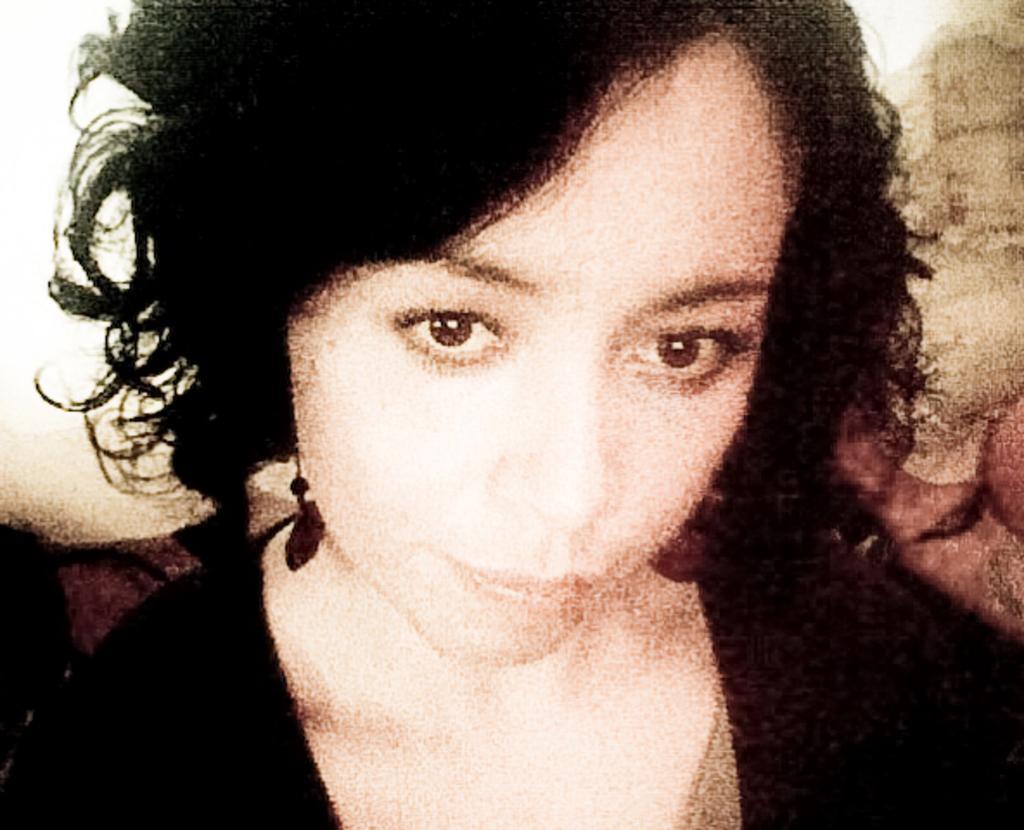How would you summarize this image in a sentence or two? In this picture there is a woman with black dress. 